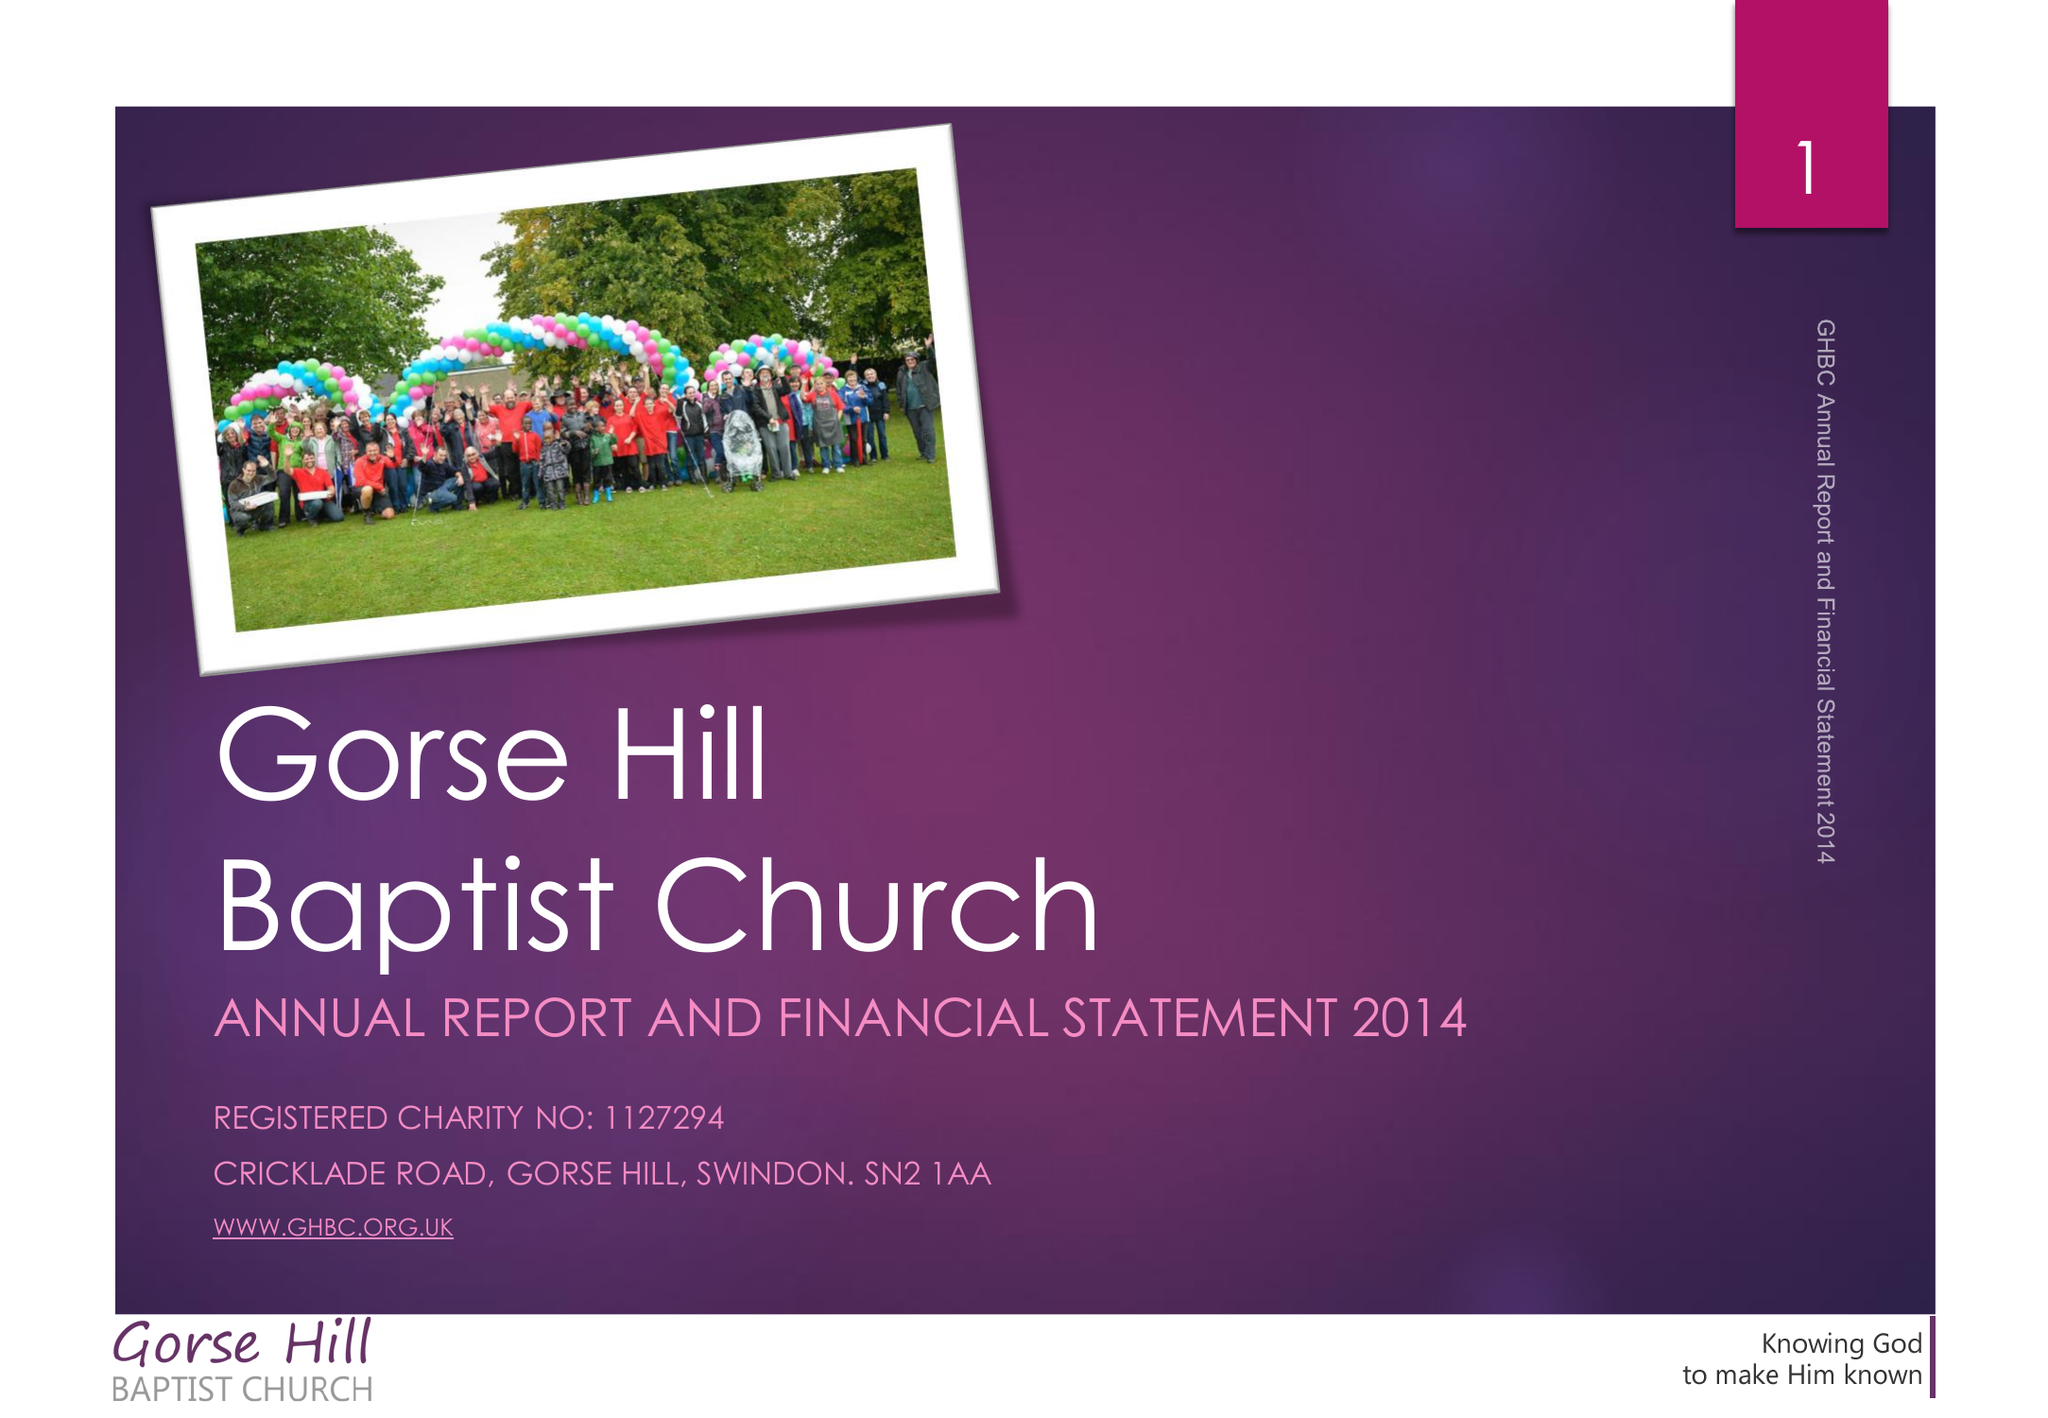What is the value for the charity_number?
Answer the question using a single word or phrase. 1127294 